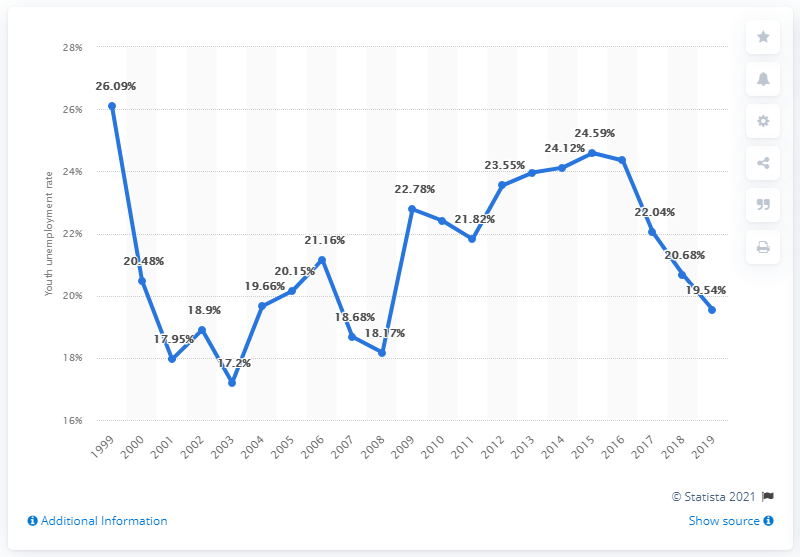Point out several critical features in this image. In 2019, the youth unemployment rate in France was 19.54%. 